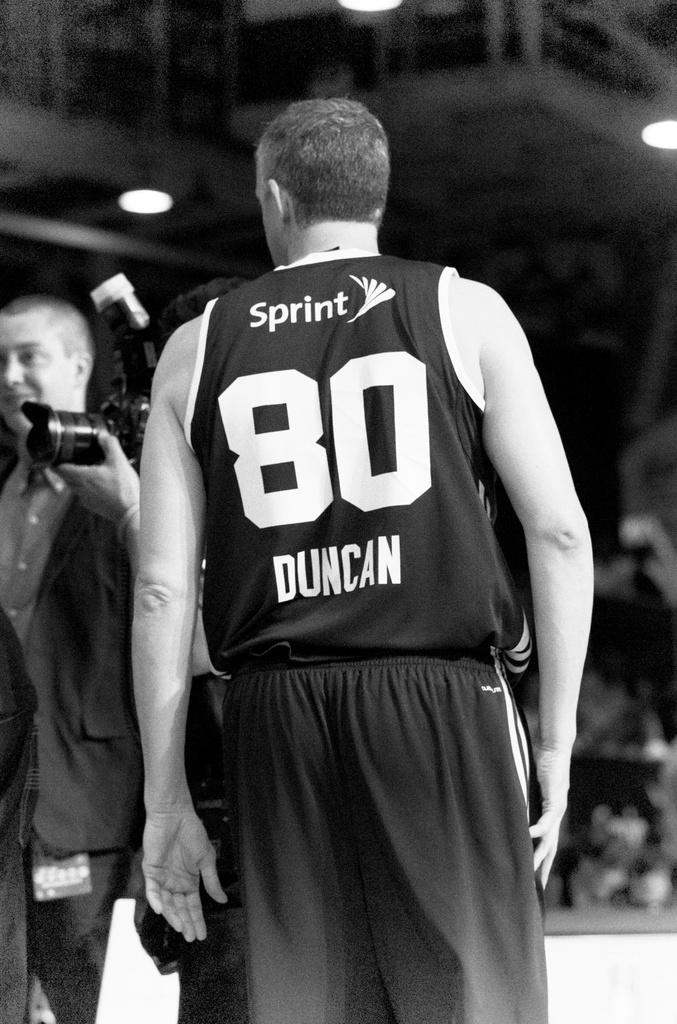<image>
Render a clear and concise summary of the photo. A basketball player with Sprint 80 Duncan on the back of his shirt 